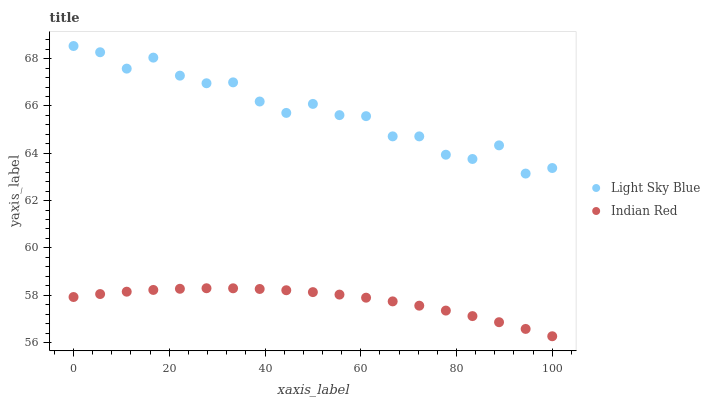Does Indian Red have the minimum area under the curve?
Answer yes or no. Yes. Does Light Sky Blue have the maximum area under the curve?
Answer yes or no. Yes. Does Indian Red have the maximum area under the curve?
Answer yes or no. No. Is Indian Red the smoothest?
Answer yes or no. Yes. Is Light Sky Blue the roughest?
Answer yes or no. Yes. Is Indian Red the roughest?
Answer yes or no. No. Does Indian Red have the lowest value?
Answer yes or no. Yes. Does Light Sky Blue have the highest value?
Answer yes or no. Yes. Does Indian Red have the highest value?
Answer yes or no. No. Is Indian Red less than Light Sky Blue?
Answer yes or no. Yes. Is Light Sky Blue greater than Indian Red?
Answer yes or no. Yes. Does Indian Red intersect Light Sky Blue?
Answer yes or no. No. 